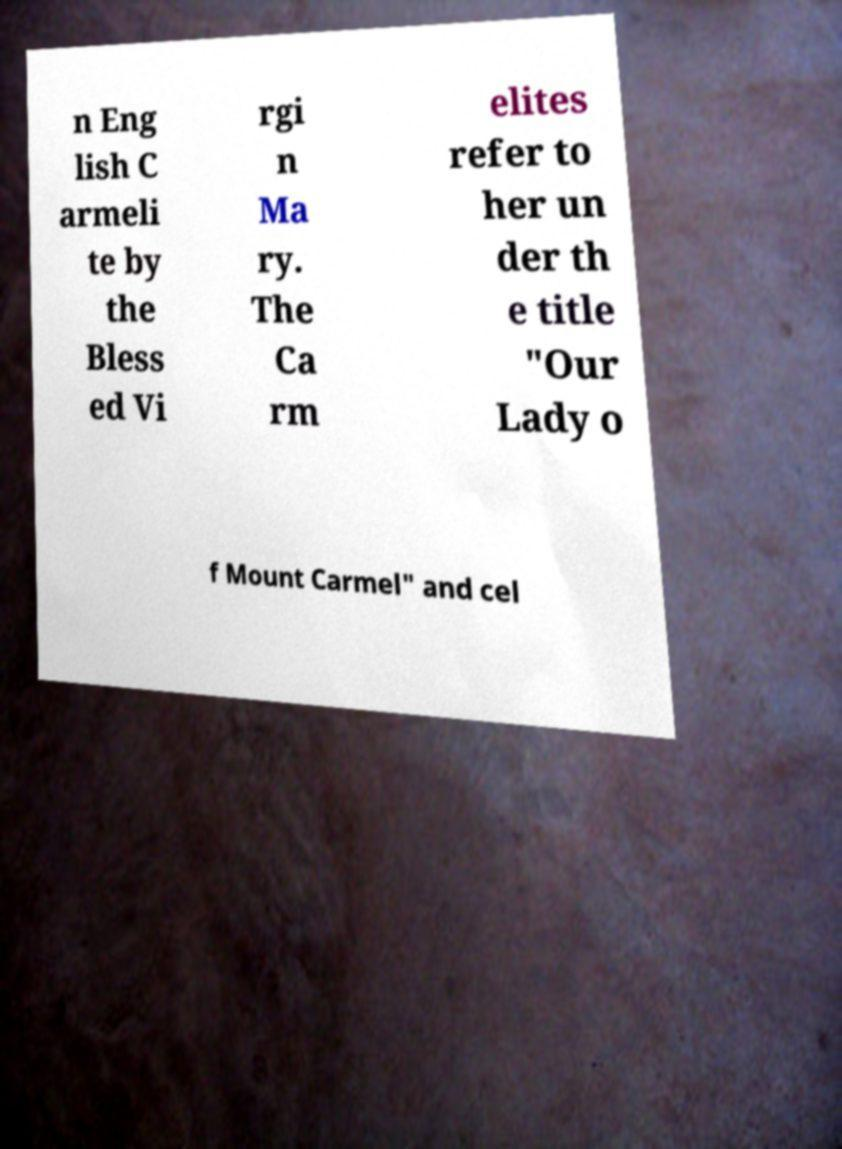For documentation purposes, I need the text within this image transcribed. Could you provide that? n Eng lish C armeli te by the Bless ed Vi rgi n Ma ry. The Ca rm elites refer to her un der th e title "Our Lady o f Mount Carmel" and cel 